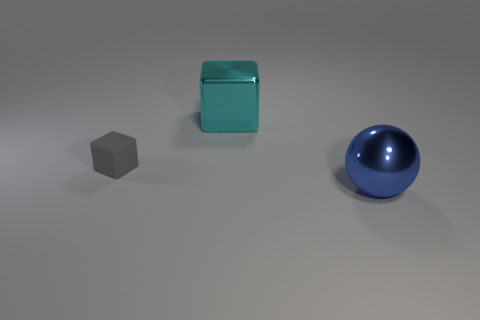Add 1 small gray matte cubes. How many objects exist? 4 Subtract all balls. How many objects are left? 2 Add 3 metal spheres. How many metal spheres exist? 4 Subtract 0 yellow cylinders. How many objects are left? 3 Subtract all purple rubber blocks. Subtract all balls. How many objects are left? 2 Add 3 tiny rubber things. How many tiny rubber things are left? 4 